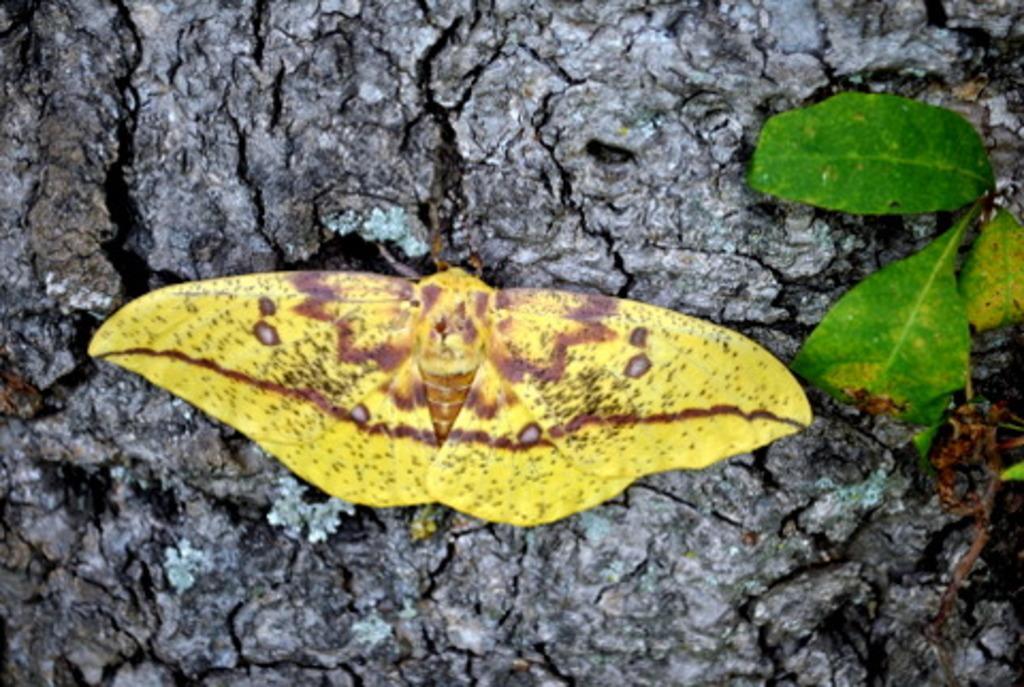How would you summarize this image in a sentence or two? The picture contains a zoom in image of a butterfly laying on a surface. 